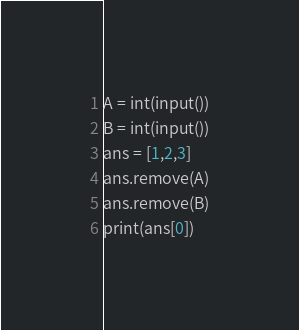<code> <loc_0><loc_0><loc_500><loc_500><_Python_>A = int(input())
B = int(input())
ans = [1,2,3]
ans.remove(A)
ans.remove(B)
print(ans[0])</code> 